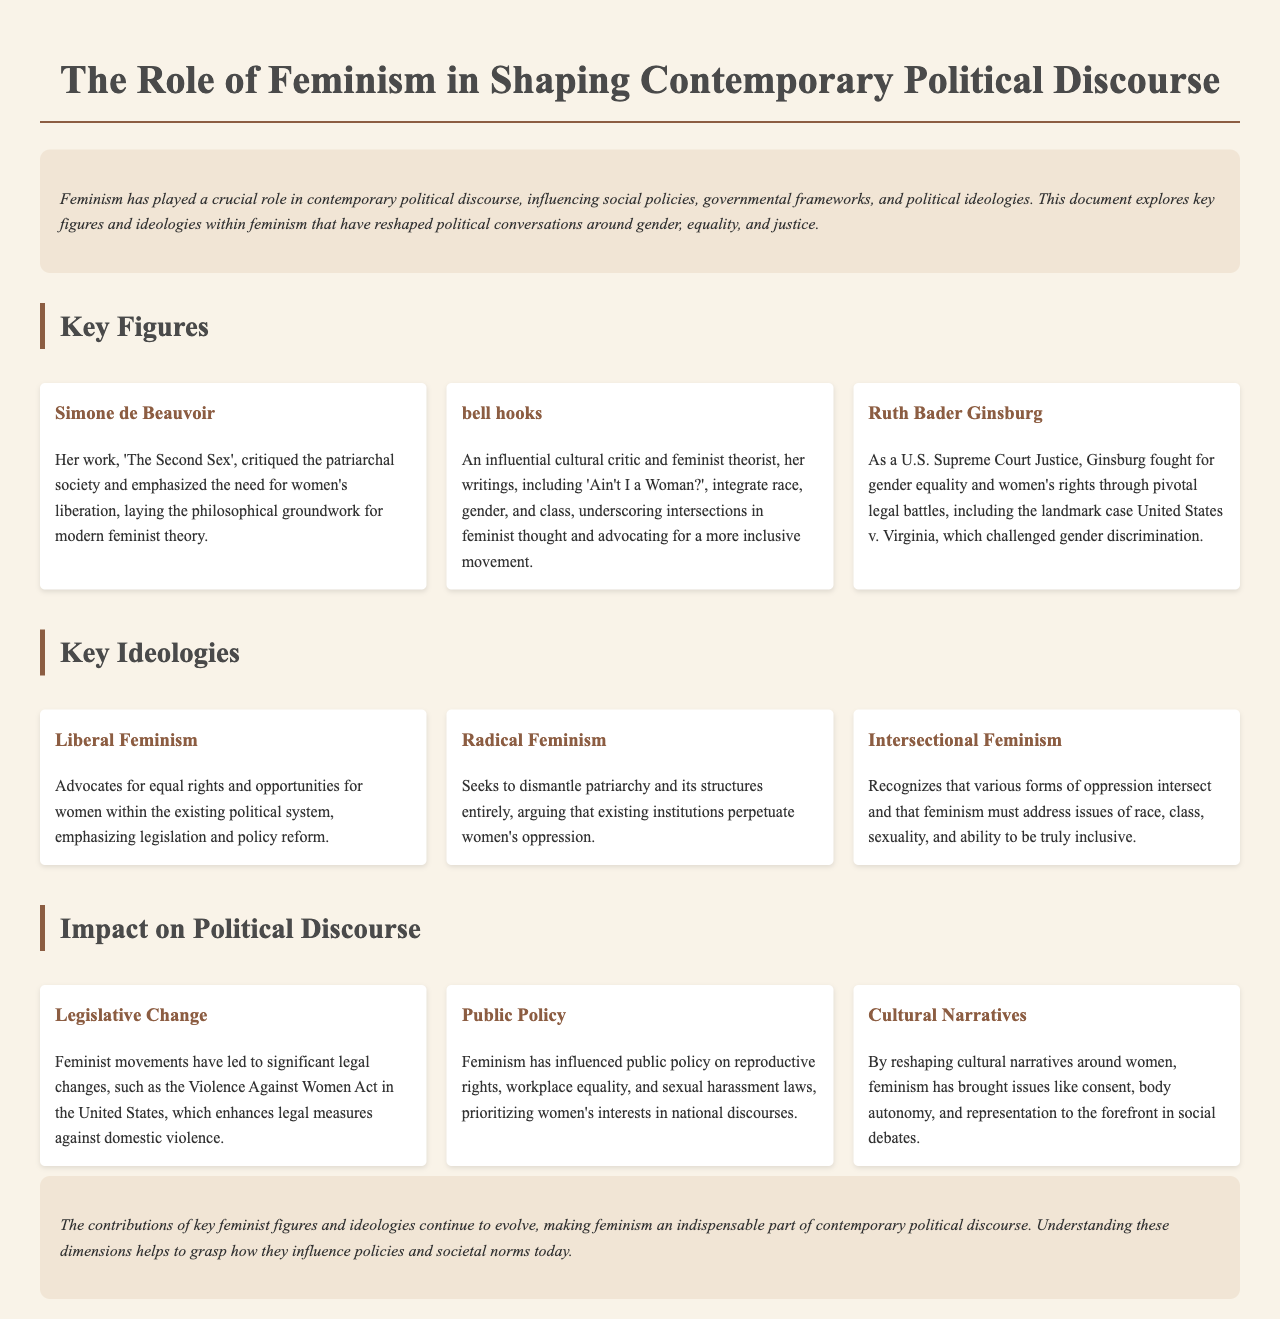What is the title of the document? The title of the document is found prominently at the top of the page.
Answer: The Role of Feminism in Shaping Contemporary Political Discourse Who wrote 'The Second Sex'? This is a key figure whose work is discussed under the section on key figures.
Answer: Simone de Beauvoir What ideology seeks to dismantle patriarchy? The section on key ideologies describes this ideology as one that challenges patriarchal structures.
Answer: Radical Feminism Which Supreme Court Justice is mentioned for fighting gender equality? The document identifies a prominent figure associated with legal battles for women's rights.
Answer: Ruth Bader Ginsburg What significant act is mentioned under legislative change? This act was highlighted in the impact section regarding feminist movements and legal reforms.
Answer: Violence Against Women Act What does intersectional feminism address? This ideology recognizes the need to consider multiple forms of oppression in its discourse.
Answer: Race, class, sexuality, and ability What is a major impact of feminism on public policy? The document outlines how feminism has influenced specific areas of national policies.
Answer: Reproductive rights Which book by bell hooks is mentioned? The key figure section identifies significant works by this feminist theorist.
Answer: Ain't I a Woman? 